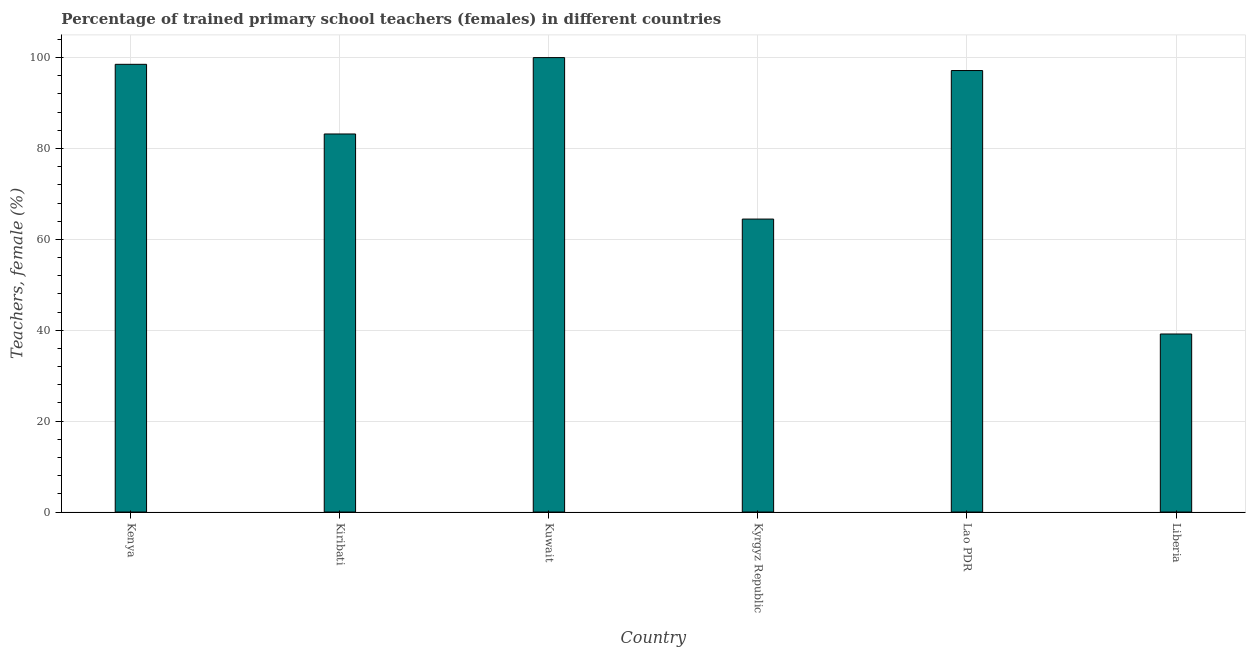Does the graph contain grids?
Provide a succinct answer. Yes. What is the title of the graph?
Ensure brevity in your answer.  Percentage of trained primary school teachers (females) in different countries. What is the label or title of the X-axis?
Provide a short and direct response. Country. What is the label or title of the Y-axis?
Keep it short and to the point. Teachers, female (%). What is the percentage of trained female teachers in Kuwait?
Provide a succinct answer. 100. Across all countries, what is the maximum percentage of trained female teachers?
Offer a very short reply. 100. Across all countries, what is the minimum percentage of trained female teachers?
Provide a succinct answer. 39.18. In which country was the percentage of trained female teachers maximum?
Your answer should be compact. Kuwait. In which country was the percentage of trained female teachers minimum?
Provide a short and direct response. Liberia. What is the sum of the percentage of trained female teachers?
Offer a very short reply. 482.51. What is the difference between the percentage of trained female teachers in Kiribati and Kyrgyz Republic?
Provide a short and direct response. 18.73. What is the average percentage of trained female teachers per country?
Your response must be concise. 80.42. What is the median percentage of trained female teachers?
Make the answer very short. 90.17. In how many countries, is the percentage of trained female teachers greater than 64 %?
Your response must be concise. 5. What is the ratio of the percentage of trained female teachers in Kiribati to that in Lao PDR?
Your response must be concise. 0.86. Is the difference between the percentage of trained female teachers in Kyrgyz Republic and Lao PDR greater than the difference between any two countries?
Your response must be concise. No. What is the difference between the highest and the second highest percentage of trained female teachers?
Make the answer very short. 1.48. Is the sum of the percentage of trained female teachers in Kyrgyz Republic and Lao PDR greater than the maximum percentage of trained female teachers across all countries?
Keep it short and to the point. Yes. What is the difference between the highest and the lowest percentage of trained female teachers?
Keep it short and to the point. 60.82. In how many countries, is the percentage of trained female teachers greater than the average percentage of trained female teachers taken over all countries?
Your response must be concise. 4. Are all the bars in the graph horizontal?
Keep it short and to the point. No. What is the difference between two consecutive major ticks on the Y-axis?
Offer a terse response. 20. What is the Teachers, female (%) of Kenya?
Give a very brief answer. 98.52. What is the Teachers, female (%) of Kiribati?
Your answer should be compact. 83.19. What is the Teachers, female (%) in Kuwait?
Your answer should be compact. 100. What is the Teachers, female (%) of Kyrgyz Republic?
Your response must be concise. 64.47. What is the Teachers, female (%) of Lao PDR?
Your response must be concise. 97.15. What is the Teachers, female (%) in Liberia?
Your response must be concise. 39.18. What is the difference between the Teachers, female (%) in Kenya and Kiribati?
Give a very brief answer. 15.33. What is the difference between the Teachers, female (%) in Kenya and Kuwait?
Your answer should be compact. -1.48. What is the difference between the Teachers, female (%) in Kenya and Kyrgyz Republic?
Keep it short and to the point. 34.05. What is the difference between the Teachers, female (%) in Kenya and Lao PDR?
Keep it short and to the point. 1.37. What is the difference between the Teachers, female (%) in Kenya and Liberia?
Your answer should be very brief. 59.34. What is the difference between the Teachers, female (%) in Kiribati and Kuwait?
Provide a succinct answer. -16.81. What is the difference between the Teachers, female (%) in Kiribati and Kyrgyz Republic?
Offer a very short reply. 18.73. What is the difference between the Teachers, female (%) in Kiribati and Lao PDR?
Give a very brief answer. -13.96. What is the difference between the Teachers, female (%) in Kiribati and Liberia?
Provide a short and direct response. 44.01. What is the difference between the Teachers, female (%) in Kuwait and Kyrgyz Republic?
Offer a terse response. 35.53. What is the difference between the Teachers, female (%) in Kuwait and Lao PDR?
Keep it short and to the point. 2.85. What is the difference between the Teachers, female (%) in Kuwait and Liberia?
Provide a short and direct response. 60.82. What is the difference between the Teachers, female (%) in Kyrgyz Republic and Lao PDR?
Your answer should be compact. -32.69. What is the difference between the Teachers, female (%) in Kyrgyz Republic and Liberia?
Offer a very short reply. 25.29. What is the difference between the Teachers, female (%) in Lao PDR and Liberia?
Give a very brief answer. 57.97. What is the ratio of the Teachers, female (%) in Kenya to that in Kiribati?
Offer a very short reply. 1.18. What is the ratio of the Teachers, female (%) in Kenya to that in Kuwait?
Your response must be concise. 0.98. What is the ratio of the Teachers, female (%) in Kenya to that in Kyrgyz Republic?
Your answer should be compact. 1.53. What is the ratio of the Teachers, female (%) in Kenya to that in Liberia?
Ensure brevity in your answer.  2.52. What is the ratio of the Teachers, female (%) in Kiribati to that in Kuwait?
Make the answer very short. 0.83. What is the ratio of the Teachers, female (%) in Kiribati to that in Kyrgyz Republic?
Provide a succinct answer. 1.29. What is the ratio of the Teachers, female (%) in Kiribati to that in Lao PDR?
Give a very brief answer. 0.86. What is the ratio of the Teachers, female (%) in Kiribati to that in Liberia?
Keep it short and to the point. 2.12. What is the ratio of the Teachers, female (%) in Kuwait to that in Kyrgyz Republic?
Your answer should be compact. 1.55. What is the ratio of the Teachers, female (%) in Kuwait to that in Lao PDR?
Your answer should be compact. 1.03. What is the ratio of the Teachers, female (%) in Kuwait to that in Liberia?
Your response must be concise. 2.55. What is the ratio of the Teachers, female (%) in Kyrgyz Republic to that in Lao PDR?
Make the answer very short. 0.66. What is the ratio of the Teachers, female (%) in Kyrgyz Republic to that in Liberia?
Give a very brief answer. 1.65. What is the ratio of the Teachers, female (%) in Lao PDR to that in Liberia?
Make the answer very short. 2.48. 